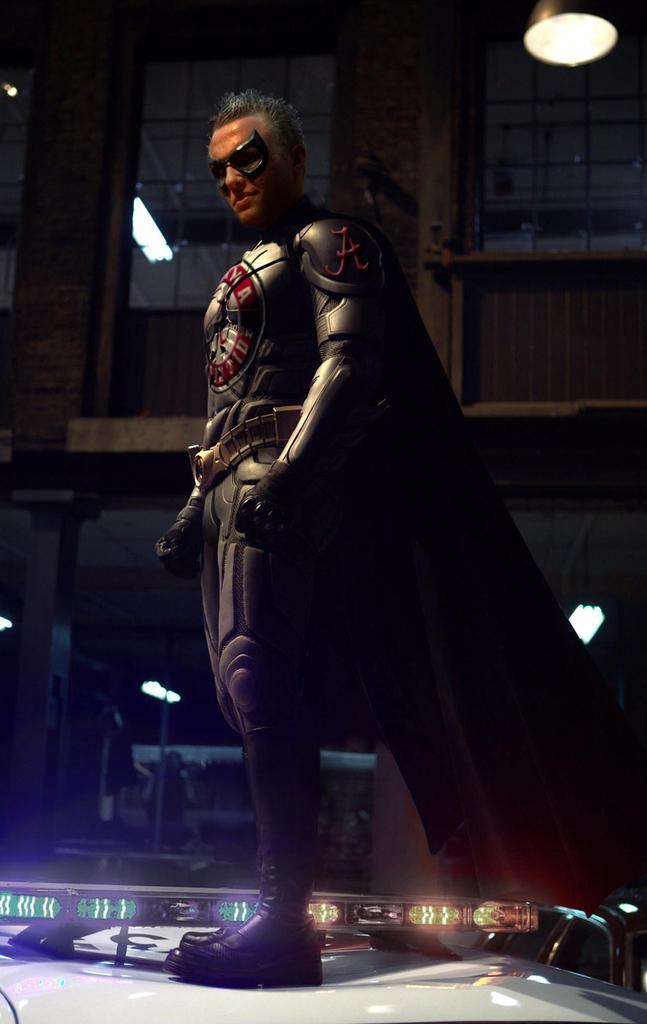Who is the main subject in the image? There is a man in the image. What is the man wearing? The man is wearing a superhero costume. What is the man doing in the image? The man is standing and giving a pose to the camera. What can be seen in the background of the image? There is a glass window and a hanging light in the background of the image. What type of drum can be seen in the man's hand in the image? There is no drum present in the image; the man is wearing a superhero costume and posing for the camera. 